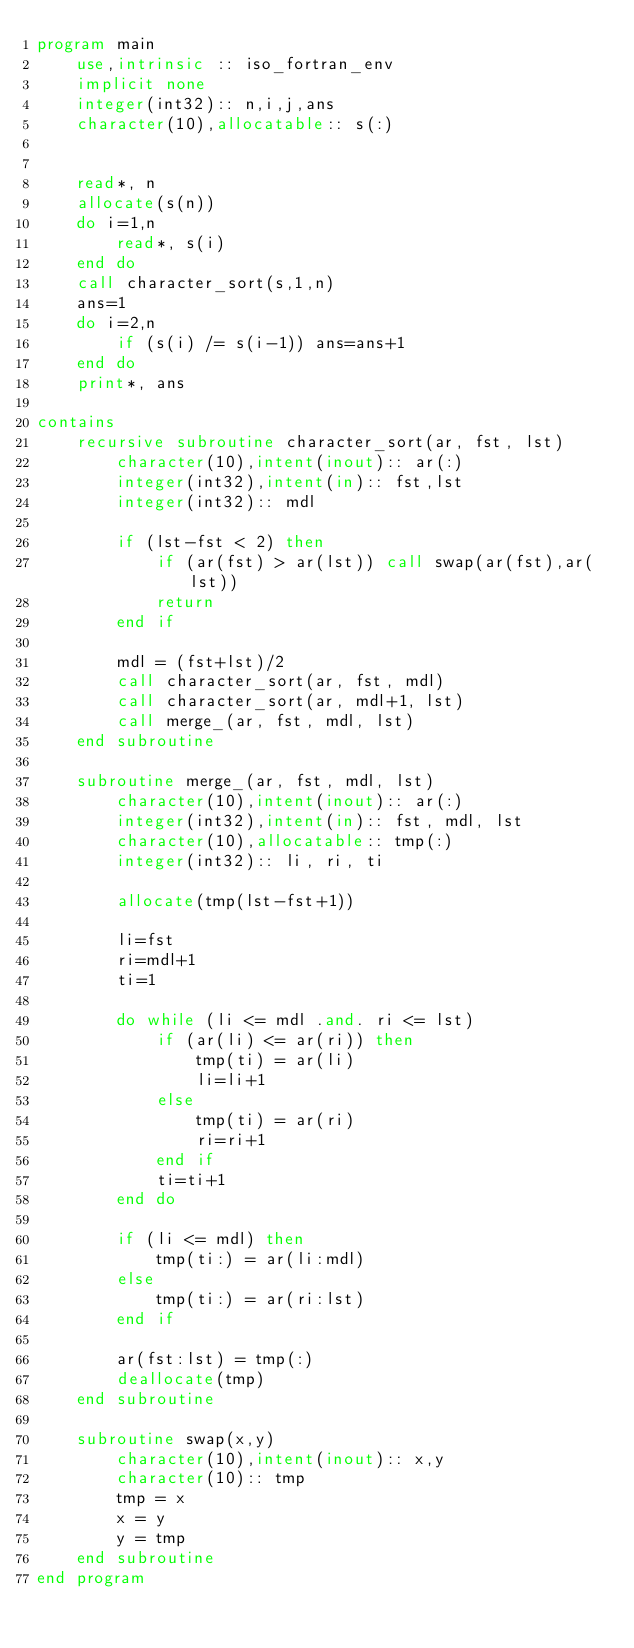<code> <loc_0><loc_0><loc_500><loc_500><_FORTRAN_>program main
    use,intrinsic :: iso_fortran_env
    implicit none
    integer(int32):: n,i,j,ans
    character(10),allocatable:: s(:)


    read*, n
    allocate(s(n))
    do i=1,n
        read*, s(i)
    end do
    call character_sort(s,1,n)
    ans=1
    do i=2,n
        if (s(i) /= s(i-1)) ans=ans+1
    end do
    print*, ans

contains
    recursive subroutine character_sort(ar, fst, lst)
        character(10),intent(inout):: ar(:)
        integer(int32),intent(in):: fst,lst
        integer(int32):: mdl

        if (lst-fst < 2) then
            if (ar(fst) > ar(lst)) call swap(ar(fst),ar(lst))
            return
        end if

        mdl = (fst+lst)/2
        call character_sort(ar, fst, mdl)
        call character_sort(ar, mdl+1, lst)
        call merge_(ar, fst, mdl, lst)
    end subroutine

    subroutine merge_(ar, fst, mdl, lst)
        character(10),intent(inout):: ar(:)
        integer(int32),intent(in):: fst, mdl, lst
        character(10),allocatable:: tmp(:)
        integer(int32):: li, ri, ti

        allocate(tmp(lst-fst+1))

        li=fst
        ri=mdl+1   
        ti=1

        do while (li <= mdl .and. ri <= lst)
            if (ar(li) <= ar(ri)) then
                tmp(ti) = ar(li)
                li=li+1
            else
                tmp(ti) = ar(ri)
                ri=ri+1
            end if
            ti=ti+1
        end do

        if (li <= mdl) then
            tmp(ti:) = ar(li:mdl)
        else
            tmp(ti:) = ar(ri:lst)
        end if

        ar(fst:lst) = tmp(:)
        deallocate(tmp)
    end subroutine

    subroutine swap(x,y)
        character(10),intent(inout):: x,y
        character(10):: tmp
        tmp = x
        x = y
        y = tmp
    end subroutine
end program </code> 